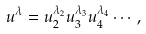<formula> <loc_0><loc_0><loc_500><loc_500>u ^ { \lambda } = u _ { 2 } ^ { \lambda _ { 2 } } u _ { 3 } ^ { \lambda _ { 3 } } u _ { 4 } ^ { \lambda _ { 4 } } \cdots ,</formula> 